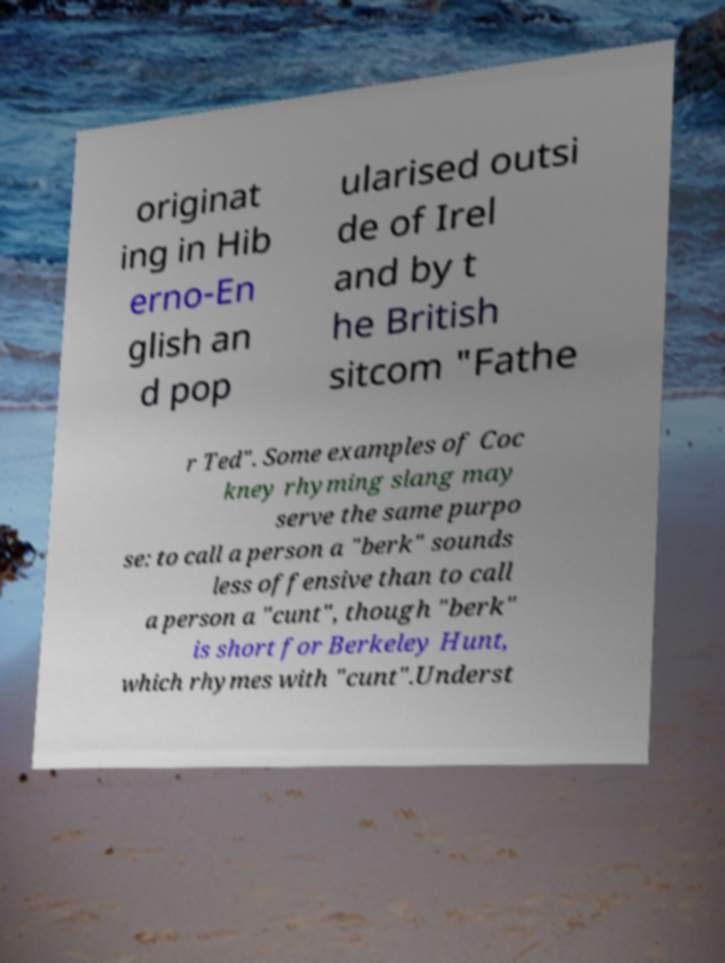Can you accurately transcribe the text from the provided image for me? originat ing in Hib erno-En glish an d pop ularised outsi de of Irel and by t he British sitcom "Fathe r Ted". Some examples of Coc kney rhyming slang may serve the same purpo se: to call a person a "berk" sounds less offensive than to call a person a "cunt", though "berk" is short for Berkeley Hunt, which rhymes with "cunt".Underst 